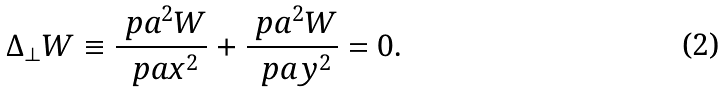<formula> <loc_0><loc_0><loc_500><loc_500>\Delta _ { \perp } W \equiv \frac { \ p a ^ { 2 } W } { \ p a x ^ { 2 } } + \frac { \ p a ^ { 2 } W } { \ p a y ^ { 2 } } = 0 .</formula> 